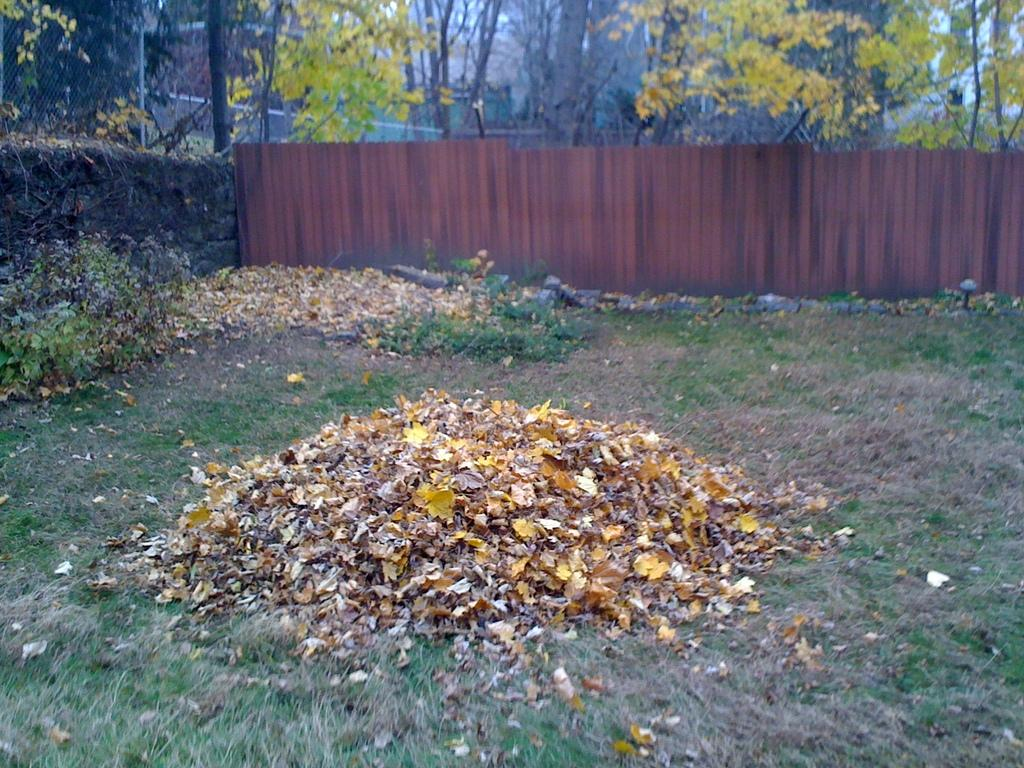What type of vegetation can be seen on the ground in the image? There are dry leaves on the ground in the image. What type of vegetation is visible besides the dry leaves? There is grass visible in the image. What other types of plants can be seen in the image? There are plants in the image. What can be seen in the background of the image? There is a fencing and a wall in the background. What type of vegetation is present at the back of the image? Trees are present at the back of the image. What type of ray is swimming in the image? There is no ray present in the image; it features dry leaves, grass, plants, fencing, a wall, and trees. What type of carriage can be seen transporting people in the image? There is no carriage present in the image. 